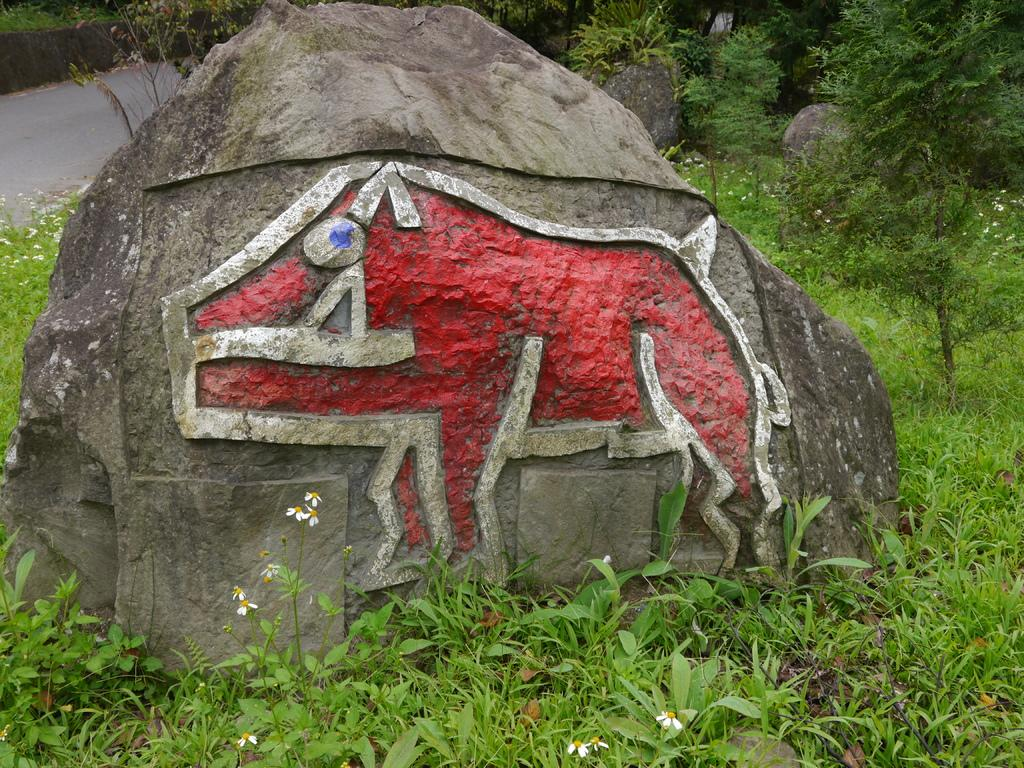What type of surface is visible in the image? There is a grass surface in the image. What can be found on the stone in the image? There is a painting of a pig on the stone in the image. What color is the painted pig? The painted pig is red in color. What other types of vegetation can be seen in the image? There are plants and trees visible in the image. What title is given to the paper in the image? There is no paper present in the image, so there is no title associated with it. Can you describe the robin's nest in the image? There is no robin or nest visible in the image; the main subjects are the grass surface, stone, and painted pig. 